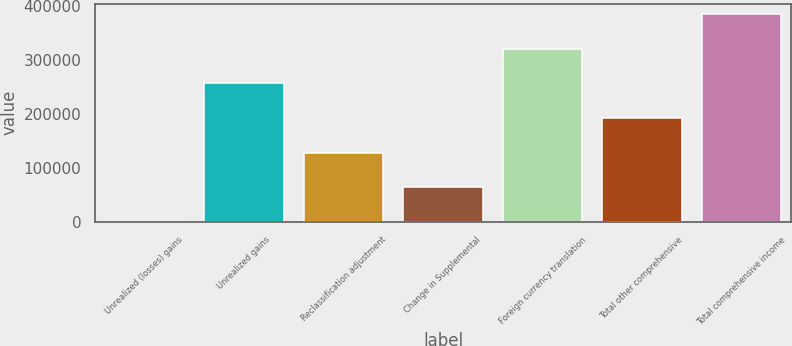Convert chart to OTSL. <chart><loc_0><loc_0><loc_500><loc_500><bar_chart><fcel>Unrealized (losses) gains<fcel>Unrealized gains<fcel>Reclassification adjustment<fcel>Change in Supplemental<fcel>Foreign currency translation<fcel>Total other comprehensive<fcel>Total comprehensive income<nl><fcel>62<fcel>256339<fcel>128200<fcel>64131.2<fcel>320408<fcel>192270<fcel>384477<nl></chart> 